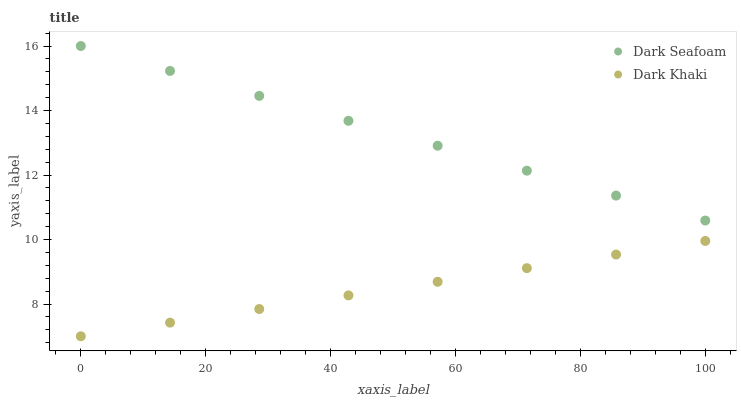Does Dark Khaki have the minimum area under the curve?
Answer yes or no. Yes. Does Dark Seafoam have the maximum area under the curve?
Answer yes or no. Yes. Does Dark Seafoam have the minimum area under the curve?
Answer yes or no. No. Is Dark Khaki the smoothest?
Answer yes or no. Yes. Is Dark Seafoam the roughest?
Answer yes or no. Yes. Is Dark Seafoam the smoothest?
Answer yes or no. No. Does Dark Khaki have the lowest value?
Answer yes or no. Yes. Does Dark Seafoam have the lowest value?
Answer yes or no. No. Does Dark Seafoam have the highest value?
Answer yes or no. Yes. Is Dark Khaki less than Dark Seafoam?
Answer yes or no. Yes. Is Dark Seafoam greater than Dark Khaki?
Answer yes or no. Yes. Does Dark Khaki intersect Dark Seafoam?
Answer yes or no. No. 